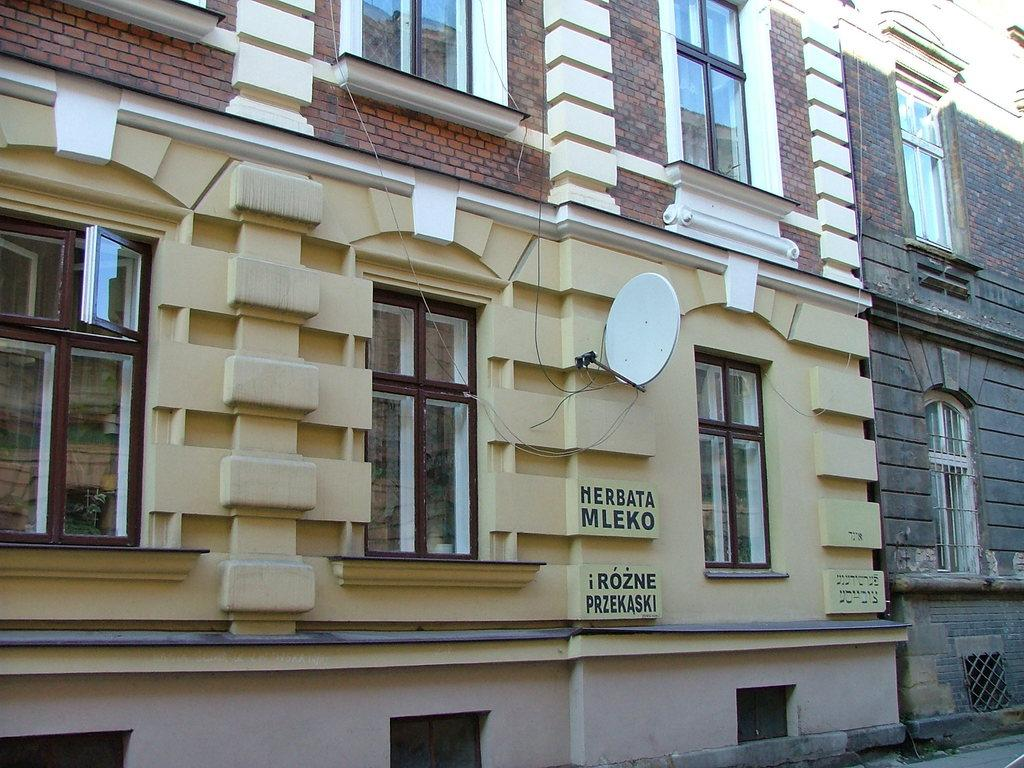What material is used for the walls of the buildings in the image? The buildings in the image have brick walls. What type of windows are present on the buildings? The buildings have glass windows. Are there any markings or text on the walls of the buildings? Yes, there is writing on the walls of the buildings. Can you identify any additional features on the walls of the buildings? There is a dish TV antenna on one of the walls. What type of carriage can be seen in the image? There is no carriage present in the image. How many blades are attached to the dish TV antenna in the image? The image does not provide enough detail to determine the number of blades on the dish TV antenna. 